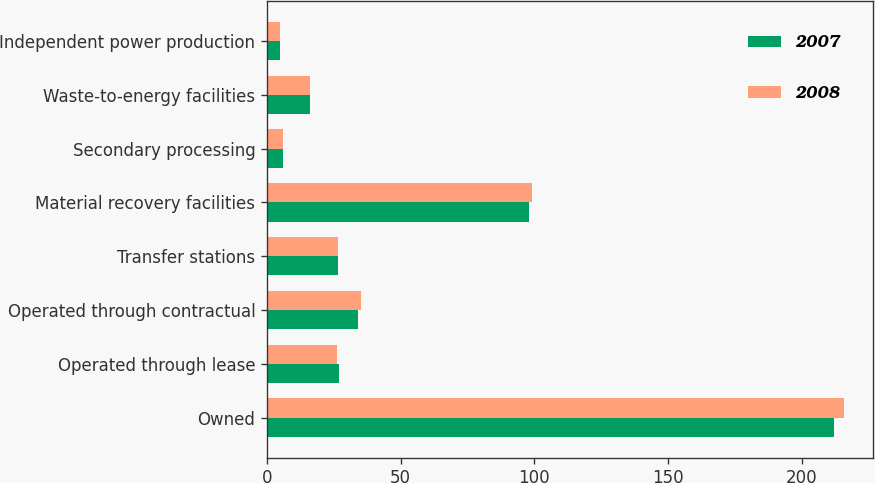Convert chart to OTSL. <chart><loc_0><loc_0><loc_500><loc_500><stacked_bar_chart><ecel><fcel>Owned<fcel>Operated through lease<fcel>Operated through contractual<fcel>Transfer stations<fcel>Material recovery facilities<fcel>Secondary processing<fcel>Waste-to-energy facilities<fcel>Independent power production<nl><fcel>2007<fcel>212<fcel>27<fcel>34<fcel>26.5<fcel>98<fcel>6<fcel>16<fcel>5<nl><fcel>2008<fcel>216<fcel>26<fcel>35<fcel>26.5<fcel>99<fcel>6<fcel>16<fcel>5<nl></chart> 